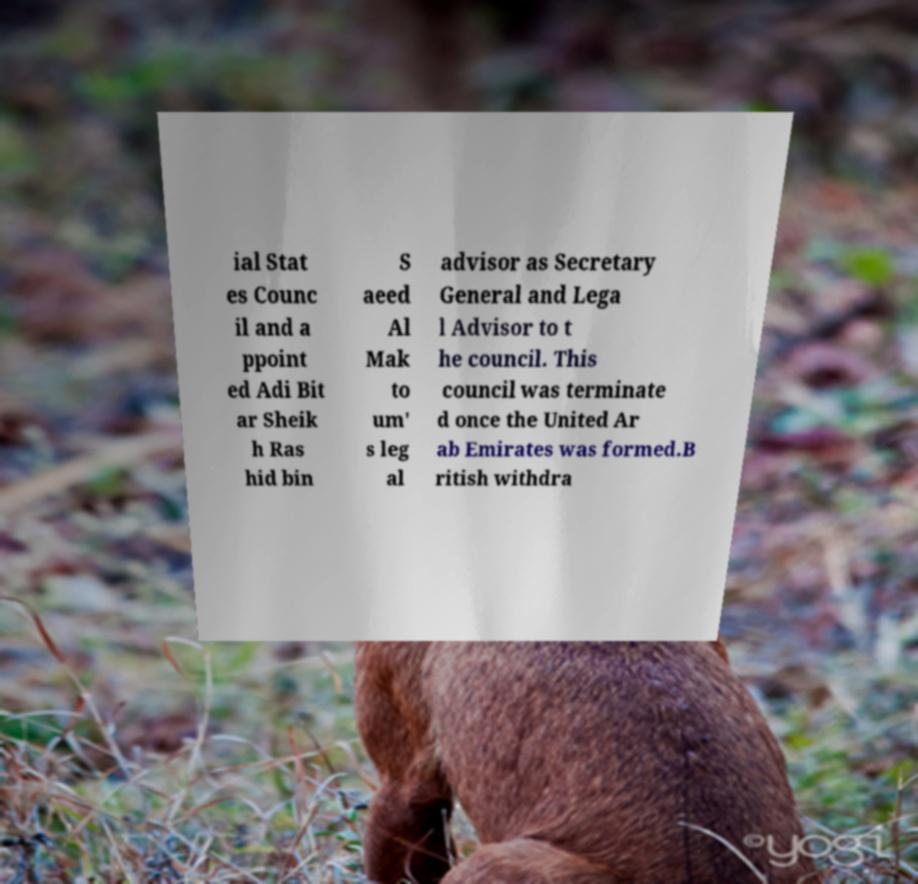Could you assist in decoding the text presented in this image and type it out clearly? ial Stat es Counc il and a ppoint ed Adi Bit ar Sheik h Ras hid bin S aeed Al Mak to um' s leg al advisor as Secretary General and Lega l Advisor to t he council. This council was terminate d once the United Ar ab Emirates was formed.B ritish withdra 